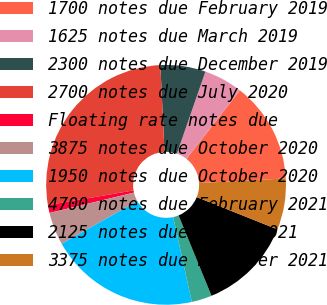Convert chart to OTSL. <chart><loc_0><loc_0><loc_500><loc_500><pie_chart><fcel>1700 notes due February 2019<fcel>1625 notes due March 2019<fcel>2300 notes due December 2019<fcel>2700 notes due July 2020<fcel>Floating rate notes due<fcel>3875 notes due October 2020<fcel>1950 notes due October 2020<fcel>4700 notes due February 2021<fcel>2125 notes due March 2021<fcel>3375 notes due November 2021<nl><fcel>13.59%<fcel>5.24%<fcel>6.08%<fcel>26.95%<fcel>1.07%<fcel>4.41%<fcel>20.27%<fcel>2.74%<fcel>12.76%<fcel>6.91%<nl></chart> 